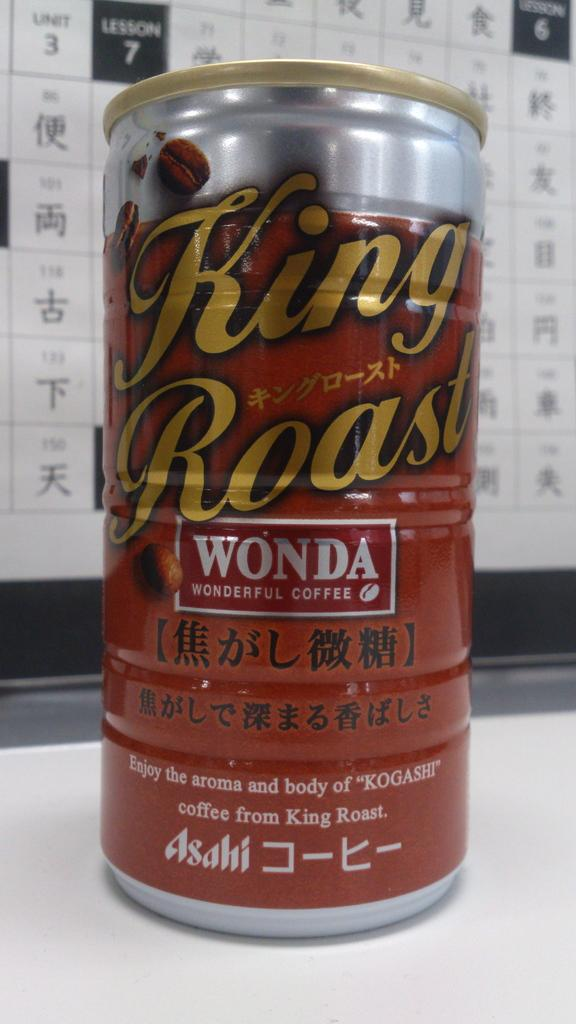What object can be seen in the image that is in red and silver color? There is a tin in the image that is in red and silver color. Where is the tin placed in the image? The tin is placed on a table in the image. What can be seen in the background of the image? There is a white color board in the background of the image. How many insects are crawling on the plate in the image? There is no plate or insects present in the image. 